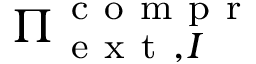Convert formula to latex. <formula><loc_0><loc_0><loc_500><loc_500>{ \Pi } _ { e x t , I } ^ { c o m p r }</formula> 